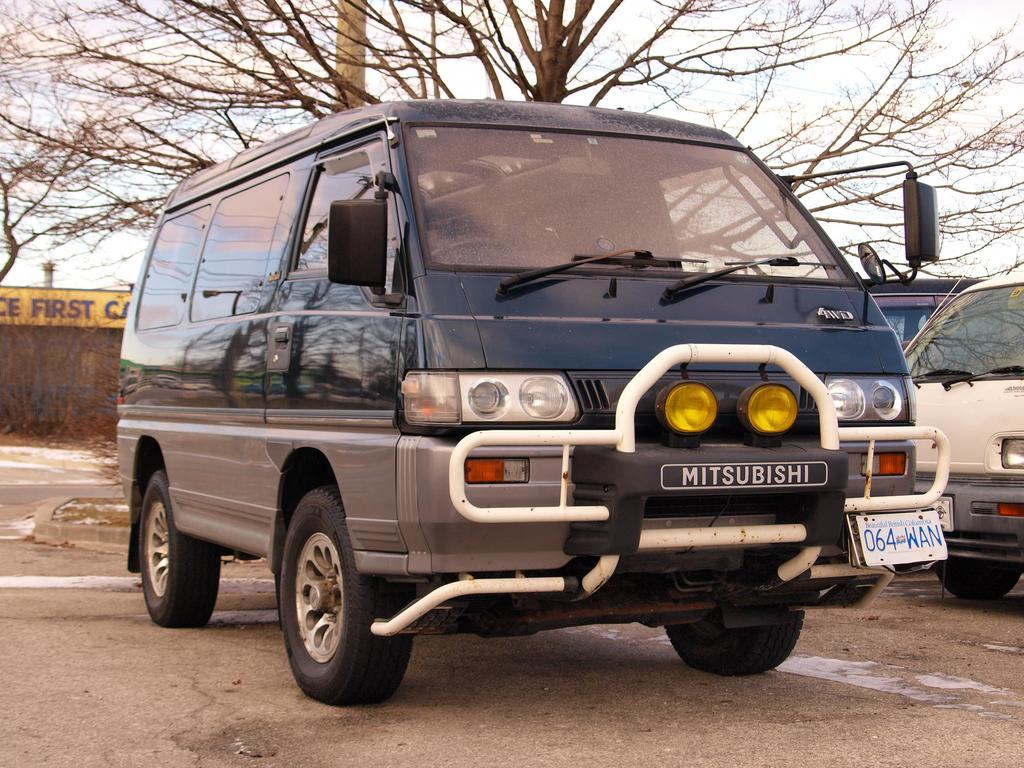What can be seen on the road in the image? There are vehicles on the road in the image. What is visible in the background of the image? There are trees in the background of the image. What feature can be observed on the vehicles? The vehicles have number plates. Can you see a parent holding a child's hand in the image? There is no parent or child present in the image. Is there a crowd of people gathered in the image? There is no crowd of people in the image; it only features vehicles on the road. 